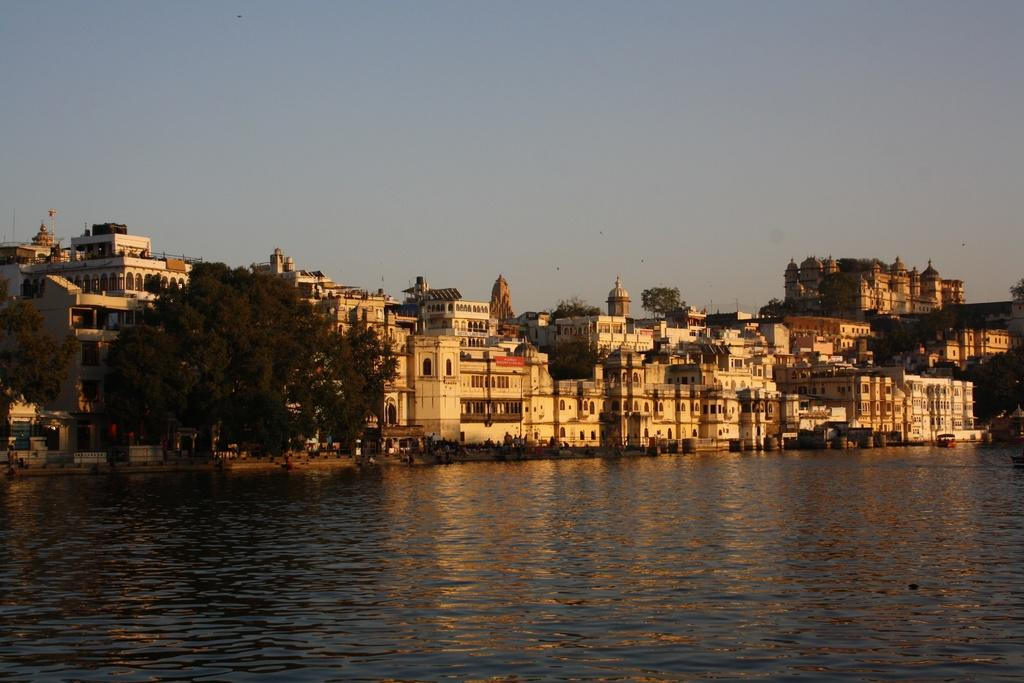What can be seen in the image? Water is visible in the image. What is visible in the background of the image? There are buildings, trees, people, and the sky visible in the background of the image. What type of amusement can be seen in the image? There is no amusement present in the image; it features water, buildings, trees, people, and the sky. Can you tell me who delivered the parcel in the image? There is no parcel present in the image, so it is not possible to determine who delivered it. 